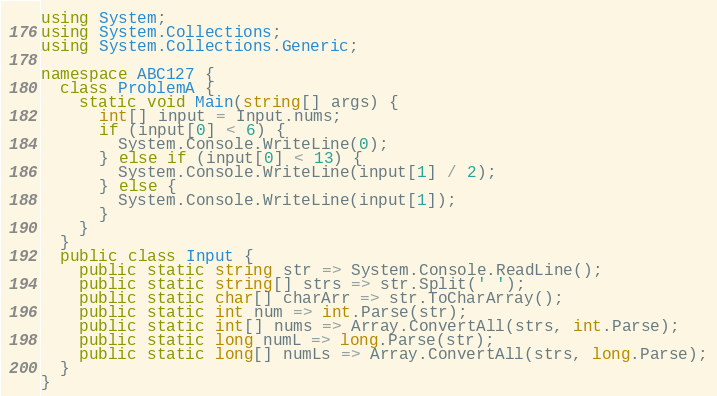<code> <loc_0><loc_0><loc_500><loc_500><_C#_>using System;
using System.Collections;
using System.Collections.Generic;

namespace ABC127 {
  class ProblemA {
    static void Main(string[] args) {
      int[] input = Input.nums;
      if (input[0] < 6) {
        System.Console.WriteLine(0);
      } else if (input[0] < 13) {
        System.Console.WriteLine(input[1] / 2);
      } else {
        System.Console.WriteLine(input[1]);
      }
    }
  }
  public class Input {
    public static string str => System.Console.ReadLine();
    public static string[] strs => str.Split(' ');
    public static char[] charArr => str.ToCharArray();
    public static int num => int.Parse(str);
    public static int[] nums => Array.ConvertAll(strs, int.Parse);
    public static long numL => long.Parse(str);
    public static long[] numLs => Array.ConvertAll(strs, long.Parse);
  }
}</code> 